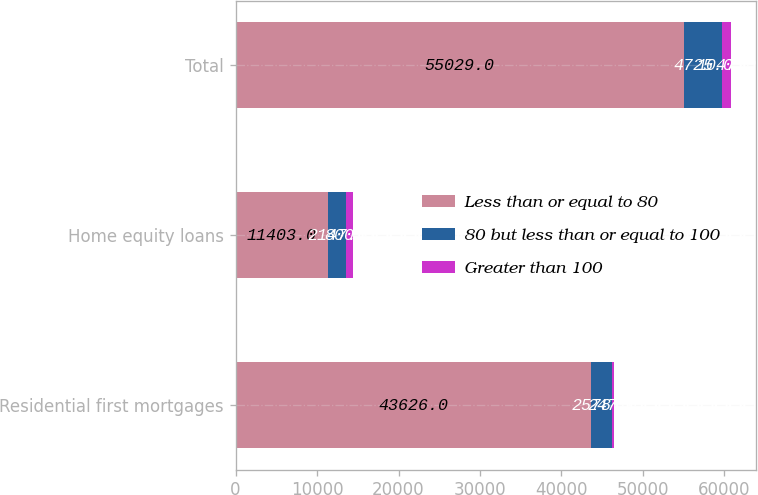Convert chart. <chart><loc_0><loc_0><loc_500><loc_500><stacked_bar_chart><ecel><fcel>Residential first mortgages<fcel>Home equity loans<fcel>Total<nl><fcel>Less than or equal to 80<fcel>43626<fcel>11403<fcel>55029<nl><fcel>80 but less than or equal to 100<fcel>2578<fcel>2147<fcel>4725<nl><fcel>Greater than 100<fcel>247<fcel>800<fcel>1047<nl></chart> 